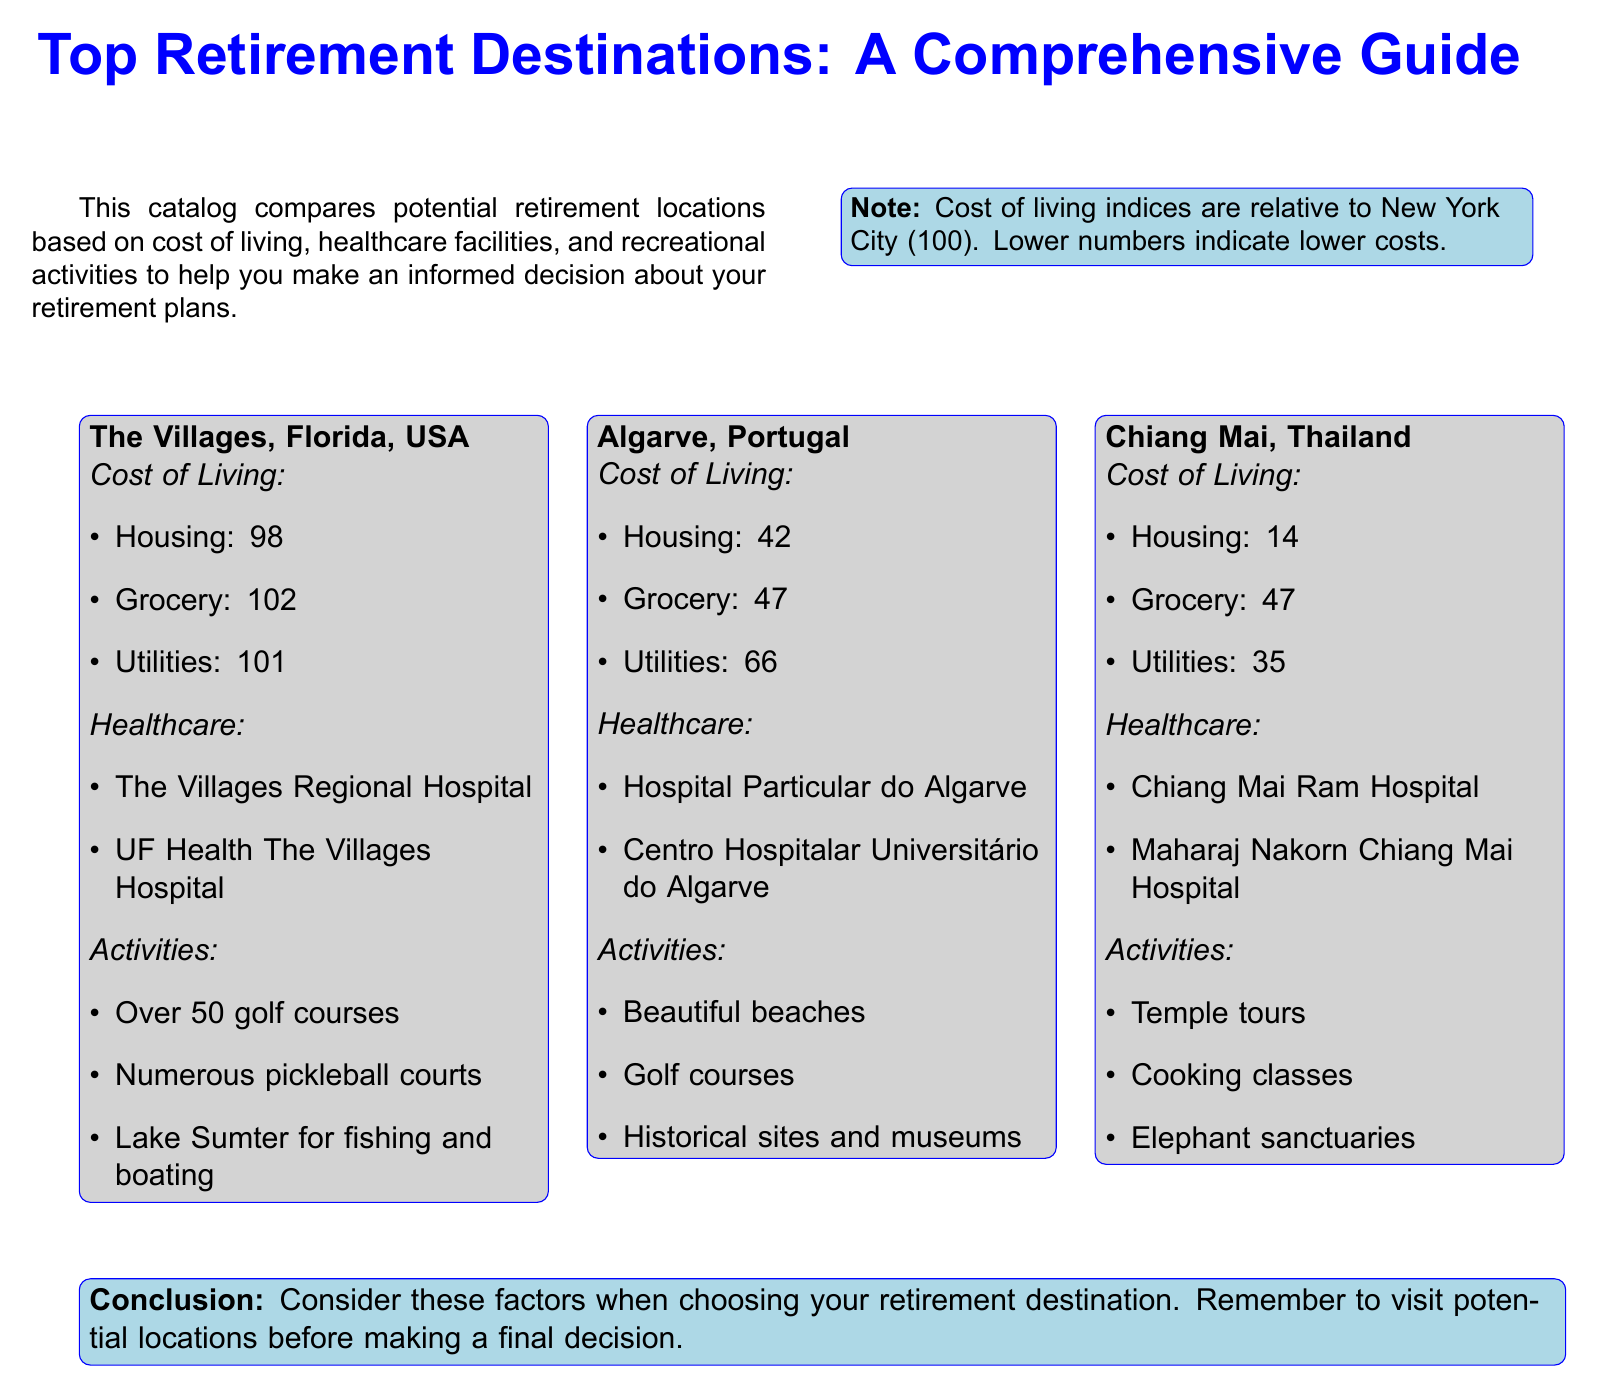What is the cost of housing in Algarve? The cost of housing in Algarve is listed as 42, which is a measure relative to New York City.
Answer: 42 What healthcare facility is available in Chiang Mai? The document lists two healthcare facilities in Chiang Mai, which includes Chiang Mai Ram Hospital.
Answer: Chiang Mai Ram Hospital How many golf courses are there in The Villages? The information mentions that there are over 50 golf courses available for activities in The Villages.
Answer: Over 50 What is the cost of utilities in Chiang Mai? The document specifies the cost of utilities in Chiang Mai as 35, indicating a lower cost compared to New York City.
Answer: 35 Which retirement location has the lowest cost of living? By comparing the provided cost indices, Chiang Mai has the lowest cost of living index at 14.
Answer: Chiang Mai What kinds of activities are available in Algarve? The document lists several recreational activities in Algarve, including beautiful beaches and golf courses.
Answer: Beautiful beaches Which healthcare facility is mentioned for The Villages? The document mentions two healthcare facilities in The Villages, with The Villages Regional Hospital being one of them.
Answer: The Villages Regional Hospital What is the cost index for grocery in The Villages? The cost index for grocery in The Villages is provided as 102, indicating higher costs relative to New York City.
Answer: 102 